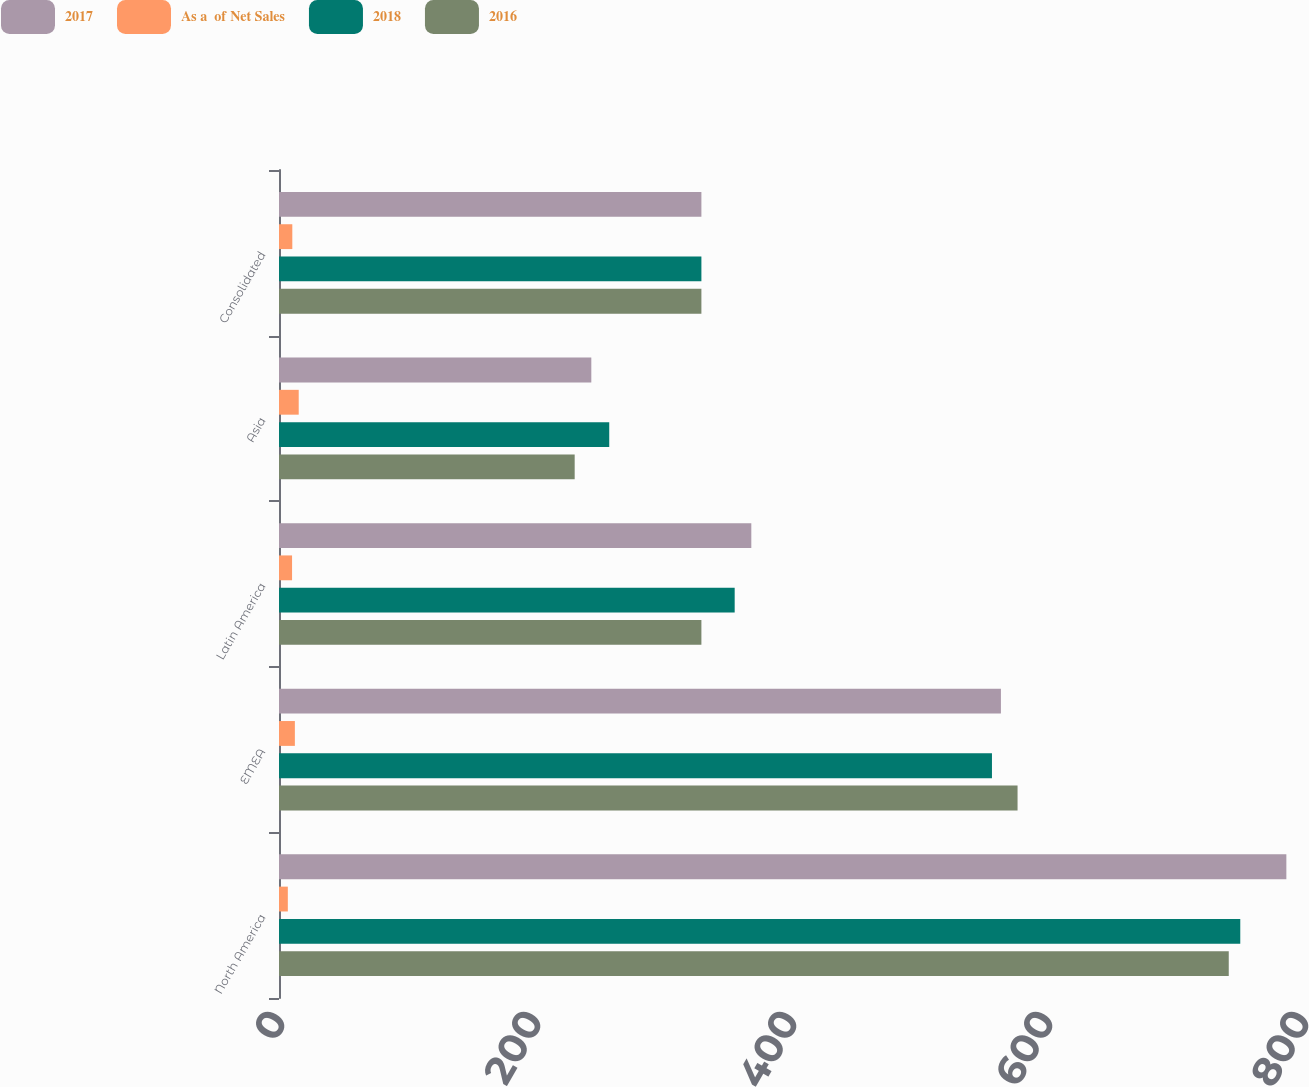Convert chart to OTSL. <chart><loc_0><loc_0><loc_500><loc_500><stacked_bar_chart><ecel><fcel>North America<fcel>EMEA<fcel>Latin America<fcel>Asia<fcel>Consolidated<nl><fcel>2017<fcel>787<fcel>564<fcel>369<fcel>244<fcel>330<nl><fcel>As a  of Net Sales<fcel>6.9<fcel>12.4<fcel>10.2<fcel>15.4<fcel>10.4<nl><fcel>2018<fcel>751<fcel>557<fcel>356<fcel>258<fcel>330<nl><fcel>2016<fcel>742<fcel>577<fcel>330<fcel>231<fcel>330<nl></chart> 